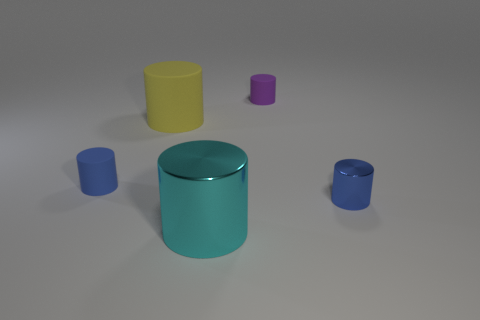Subtract all cyan cylinders. How many cylinders are left? 4 Subtract all cyan cylinders. How many cylinders are left? 4 Subtract 1 cylinders. How many cylinders are left? 4 Subtract all green cylinders. Subtract all purple spheres. How many cylinders are left? 5 Add 4 large rubber cylinders. How many objects exist? 9 Add 3 large metal objects. How many large metal objects exist? 4 Subtract 0 cyan balls. How many objects are left? 5 Subtract all yellow metal objects. Subtract all tiny blue matte objects. How many objects are left? 4 Add 3 tiny blue metallic objects. How many tiny blue metallic objects are left? 4 